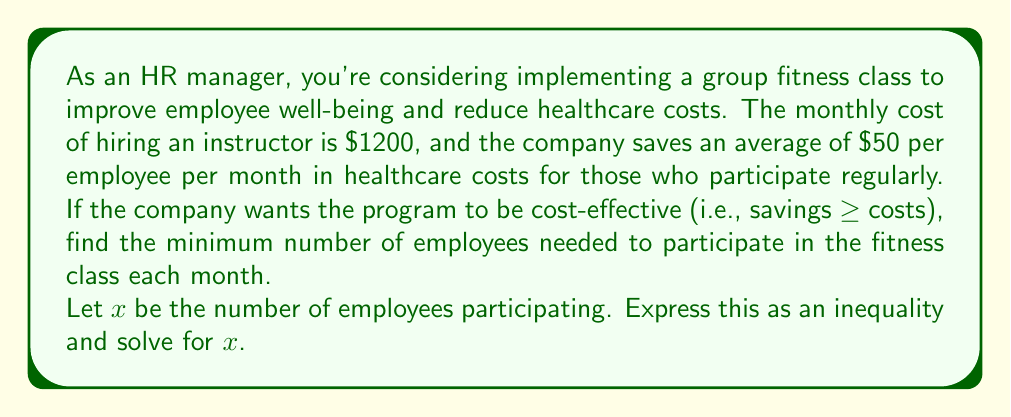Teach me how to tackle this problem. To solve this problem, we need to set up an inequality where the savings are greater than or equal to the costs:

1) Let's express the savings:
   $50x$ (where $x$ is the number of employees participating)

2) The cost is fixed at $1200 per month

3) For the program to be cost-effective, we need:
   $$50x \geq 1200$$

4) To solve for $x$, divide both sides by 50:
   $$x \geq \frac{1200}{50}$$

5) Simplify:
   $$x \geq 24$$

6) Since we can't have a fractional number of employees, we need to round up to the nearest whole number.

Therefore, the minimum number of employees needed is 24.
Answer: The minimum number of employees needed to make the group fitness class cost-effective is 24. 